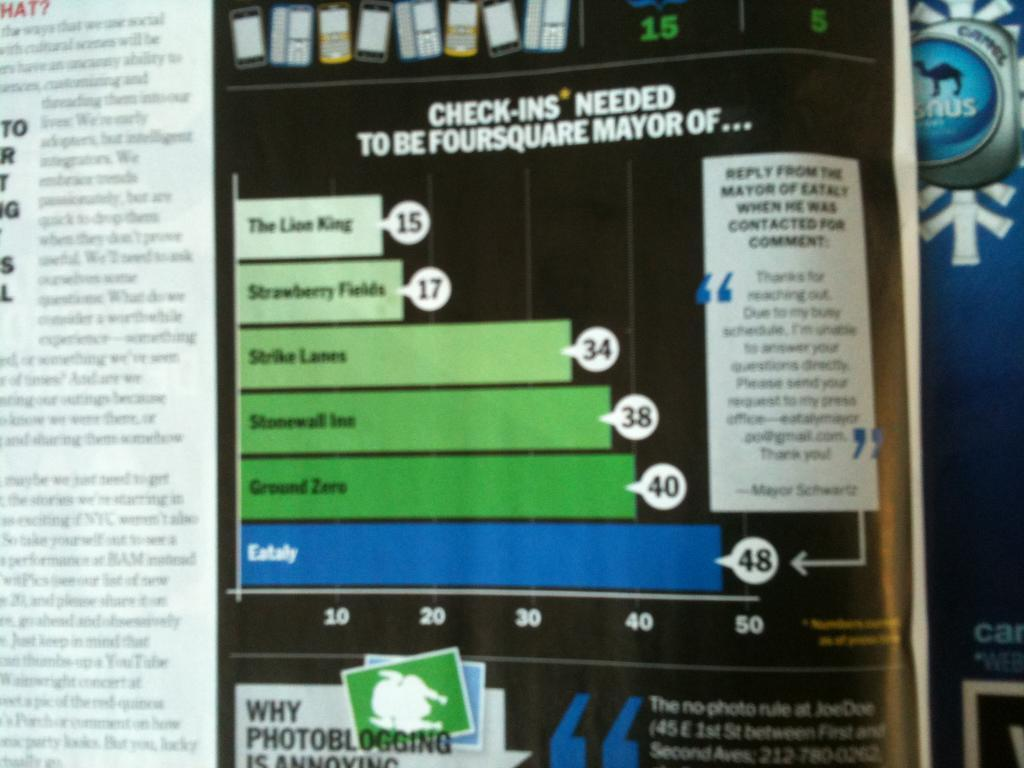<image>
Write a terse but informative summary of the picture. A diagram telling how to be the Foursquare Mayor of various films. 